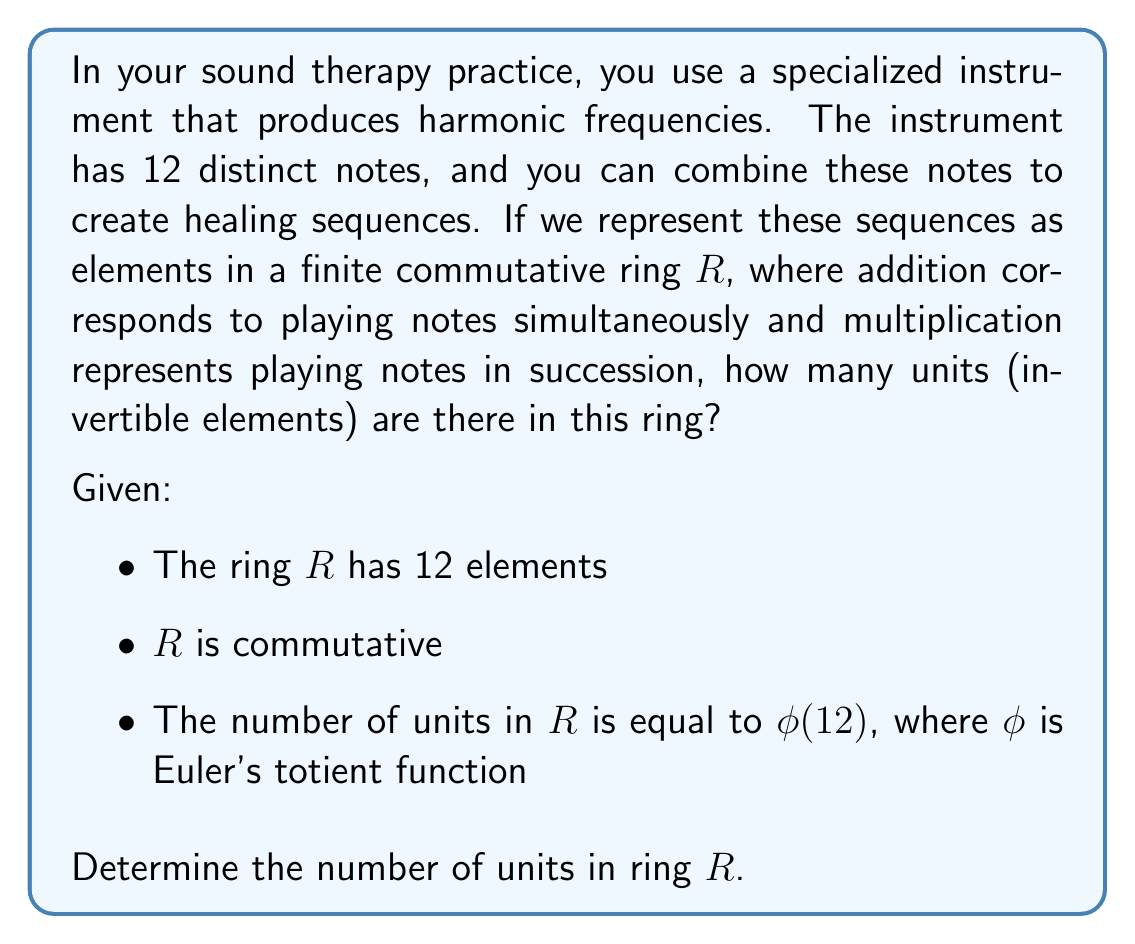Teach me how to tackle this problem. To solve this problem, we need to calculate Euler's totient function $\phi(12)$. Let's break it down step-by-step:

1) Euler's totient function $\phi(n)$ counts the number of integers up to $n$ that are coprime to $n$.

2) To calculate $\phi(12)$, we need to find the prime factorization of 12:
   $12 = 2^2 \times 3$

3) For a prime power $p^k$, the formula for $\phi(p^k)$ is:
   $\phi(p^k) = p^k - p^{k-1} = p^k(1 - \frac{1}{p})$

4) For $\phi(12)$, we can use the multiplicative property of the totient function:
   $\phi(12) = \phi(2^2) \times \phi(3)$

5) Calculate $\phi(2^2)$:
   $\phi(2^2) = 2^2 - 2^1 = 4 - 2 = 2$

6) Calculate $\phi(3)$:
   $\phi(3) = 3 - 1 = 2$

7) Now, we can multiply these results:
   $\phi(12) = \phi(2^2) \times \phi(3) = 2 \times 2 = 4$

Therefore, there are 4 units in the ring $R$.
Answer: 4 